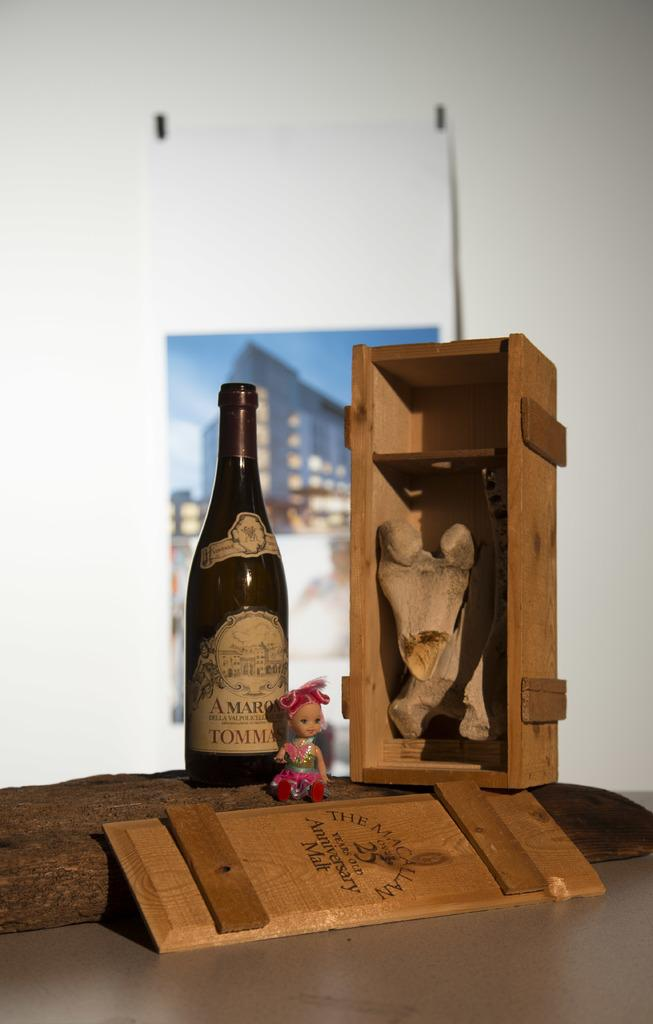Where was the image taken? The image was taken in a room. What furniture is present in the room? There is a table in the room. What objects are on the table? There is a name board, a doll, a bottle, and a box on the table. What is the background of the bottle? The background of the bottle is a wall. How many balls are visible in the image? There are no balls visible in the image. What type of voyage is the doll about to embark on in the image? There is no indication of a voyage in the image; it simply shows a doll on a table. 